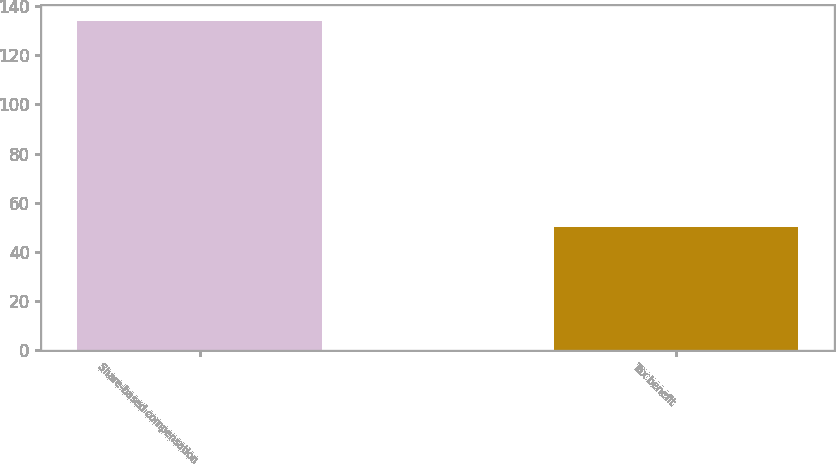Convert chart to OTSL. <chart><loc_0><loc_0><loc_500><loc_500><bar_chart><fcel>Share-based compensation<fcel>Tax benefit<nl><fcel>134<fcel>50<nl></chart> 